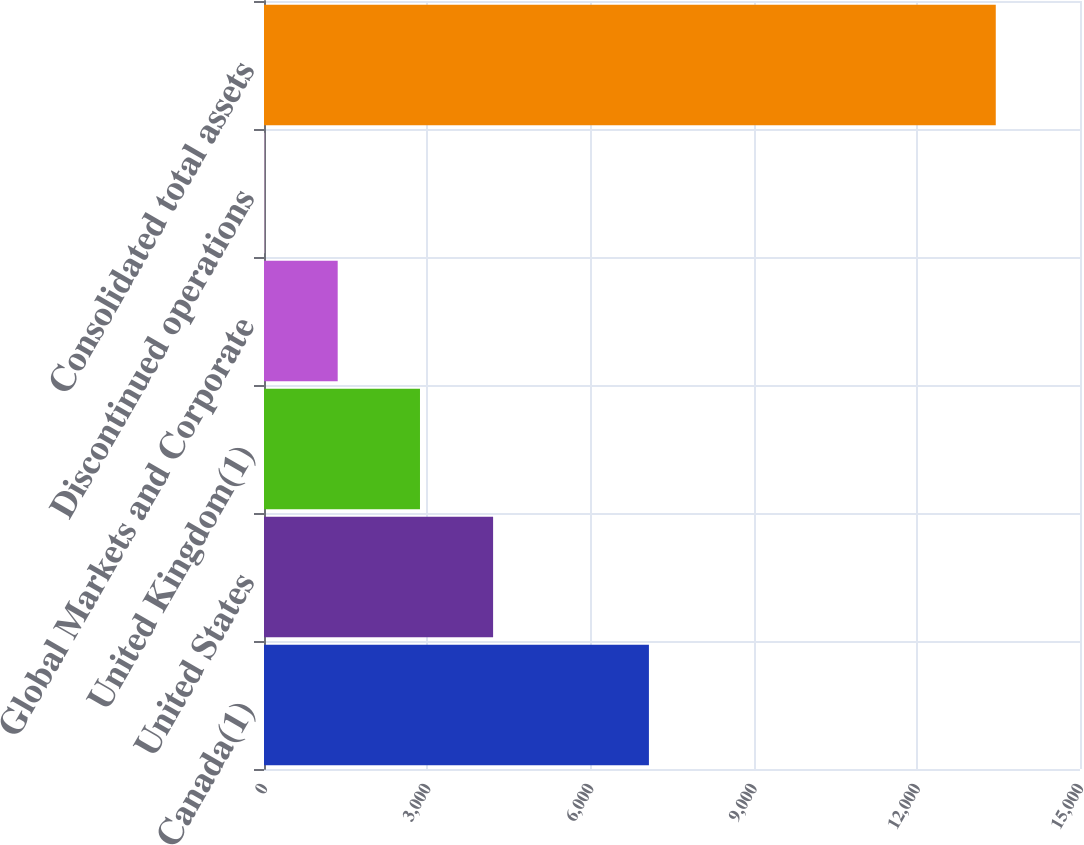<chart> <loc_0><loc_0><loc_500><loc_500><bar_chart><fcel>Canada(1)<fcel>United States<fcel>United Kingdom(1)<fcel>Global Markets and Corporate<fcel>Discontinued operations<fcel>Consolidated total assets<nl><fcel>7075.8<fcel>4211.4<fcel>2867.3<fcel>1354.7<fcel>10.6<fcel>13451.6<nl></chart> 